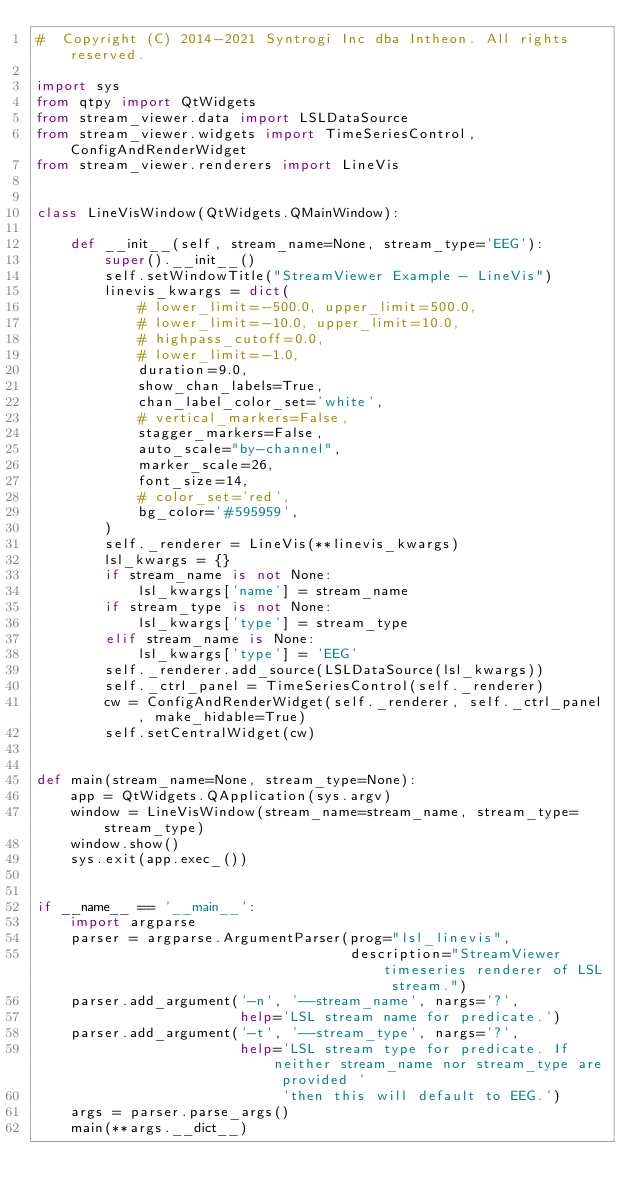Convert code to text. <code><loc_0><loc_0><loc_500><loc_500><_Python_>#  Copyright (C) 2014-2021 Syntrogi Inc dba Intheon. All rights reserved.

import sys
from qtpy import QtWidgets
from stream_viewer.data import LSLDataSource
from stream_viewer.widgets import TimeSeriesControl, ConfigAndRenderWidget
from stream_viewer.renderers import LineVis


class LineVisWindow(QtWidgets.QMainWindow):

    def __init__(self, stream_name=None, stream_type='EEG'):
        super().__init__()
        self.setWindowTitle("StreamViewer Example - LineVis")
        linevis_kwargs = dict(
            # lower_limit=-500.0, upper_limit=500.0,
            # lower_limit=-10.0, upper_limit=10.0,
            # highpass_cutoff=0.0,
            # lower_limit=-1.0,
            duration=9.0,
            show_chan_labels=True,
            chan_label_color_set='white',
            # vertical_markers=False,
            stagger_markers=False,
            auto_scale="by-channel",
            marker_scale=26,
            font_size=14,
            # color_set='red',
            bg_color='#595959',
        )
        self._renderer = LineVis(**linevis_kwargs)
        lsl_kwargs = {}
        if stream_name is not None:
            lsl_kwargs['name'] = stream_name
        if stream_type is not None:
            lsl_kwargs['type'] = stream_type
        elif stream_name is None:
            lsl_kwargs['type'] = 'EEG'
        self._renderer.add_source(LSLDataSource(lsl_kwargs))
        self._ctrl_panel = TimeSeriesControl(self._renderer)
        cw = ConfigAndRenderWidget(self._renderer, self._ctrl_panel, make_hidable=True)
        self.setCentralWidget(cw)


def main(stream_name=None, stream_type=None):
    app = QtWidgets.QApplication(sys.argv)
    window = LineVisWindow(stream_name=stream_name, stream_type=stream_type)
    window.show()
    sys.exit(app.exec_())


if __name__ == '__main__':
    import argparse
    parser = argparse.ArgumentParser(prog="lsl_linevis",
                                     description="StreamViewer timeseries renderer of LSL stream.")
    parser.add_argument('-n', '--stream_name', nargs='?',
                        help='LSL stream name for predicate.')
    parser.add_argument('-t', '--stream_type', nargs='?',
                        help='LSL stream type for predicate. If neither stream_name nor stream_type are provided '
                             'then this will default to EEG.')
    args = parser.parse_args()
    main(**args.__dict__)
</code> 